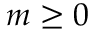Convert formula to latex. <formula><loc_0><loc_0><loc_500><loc_500>m \geq 0</formula> 